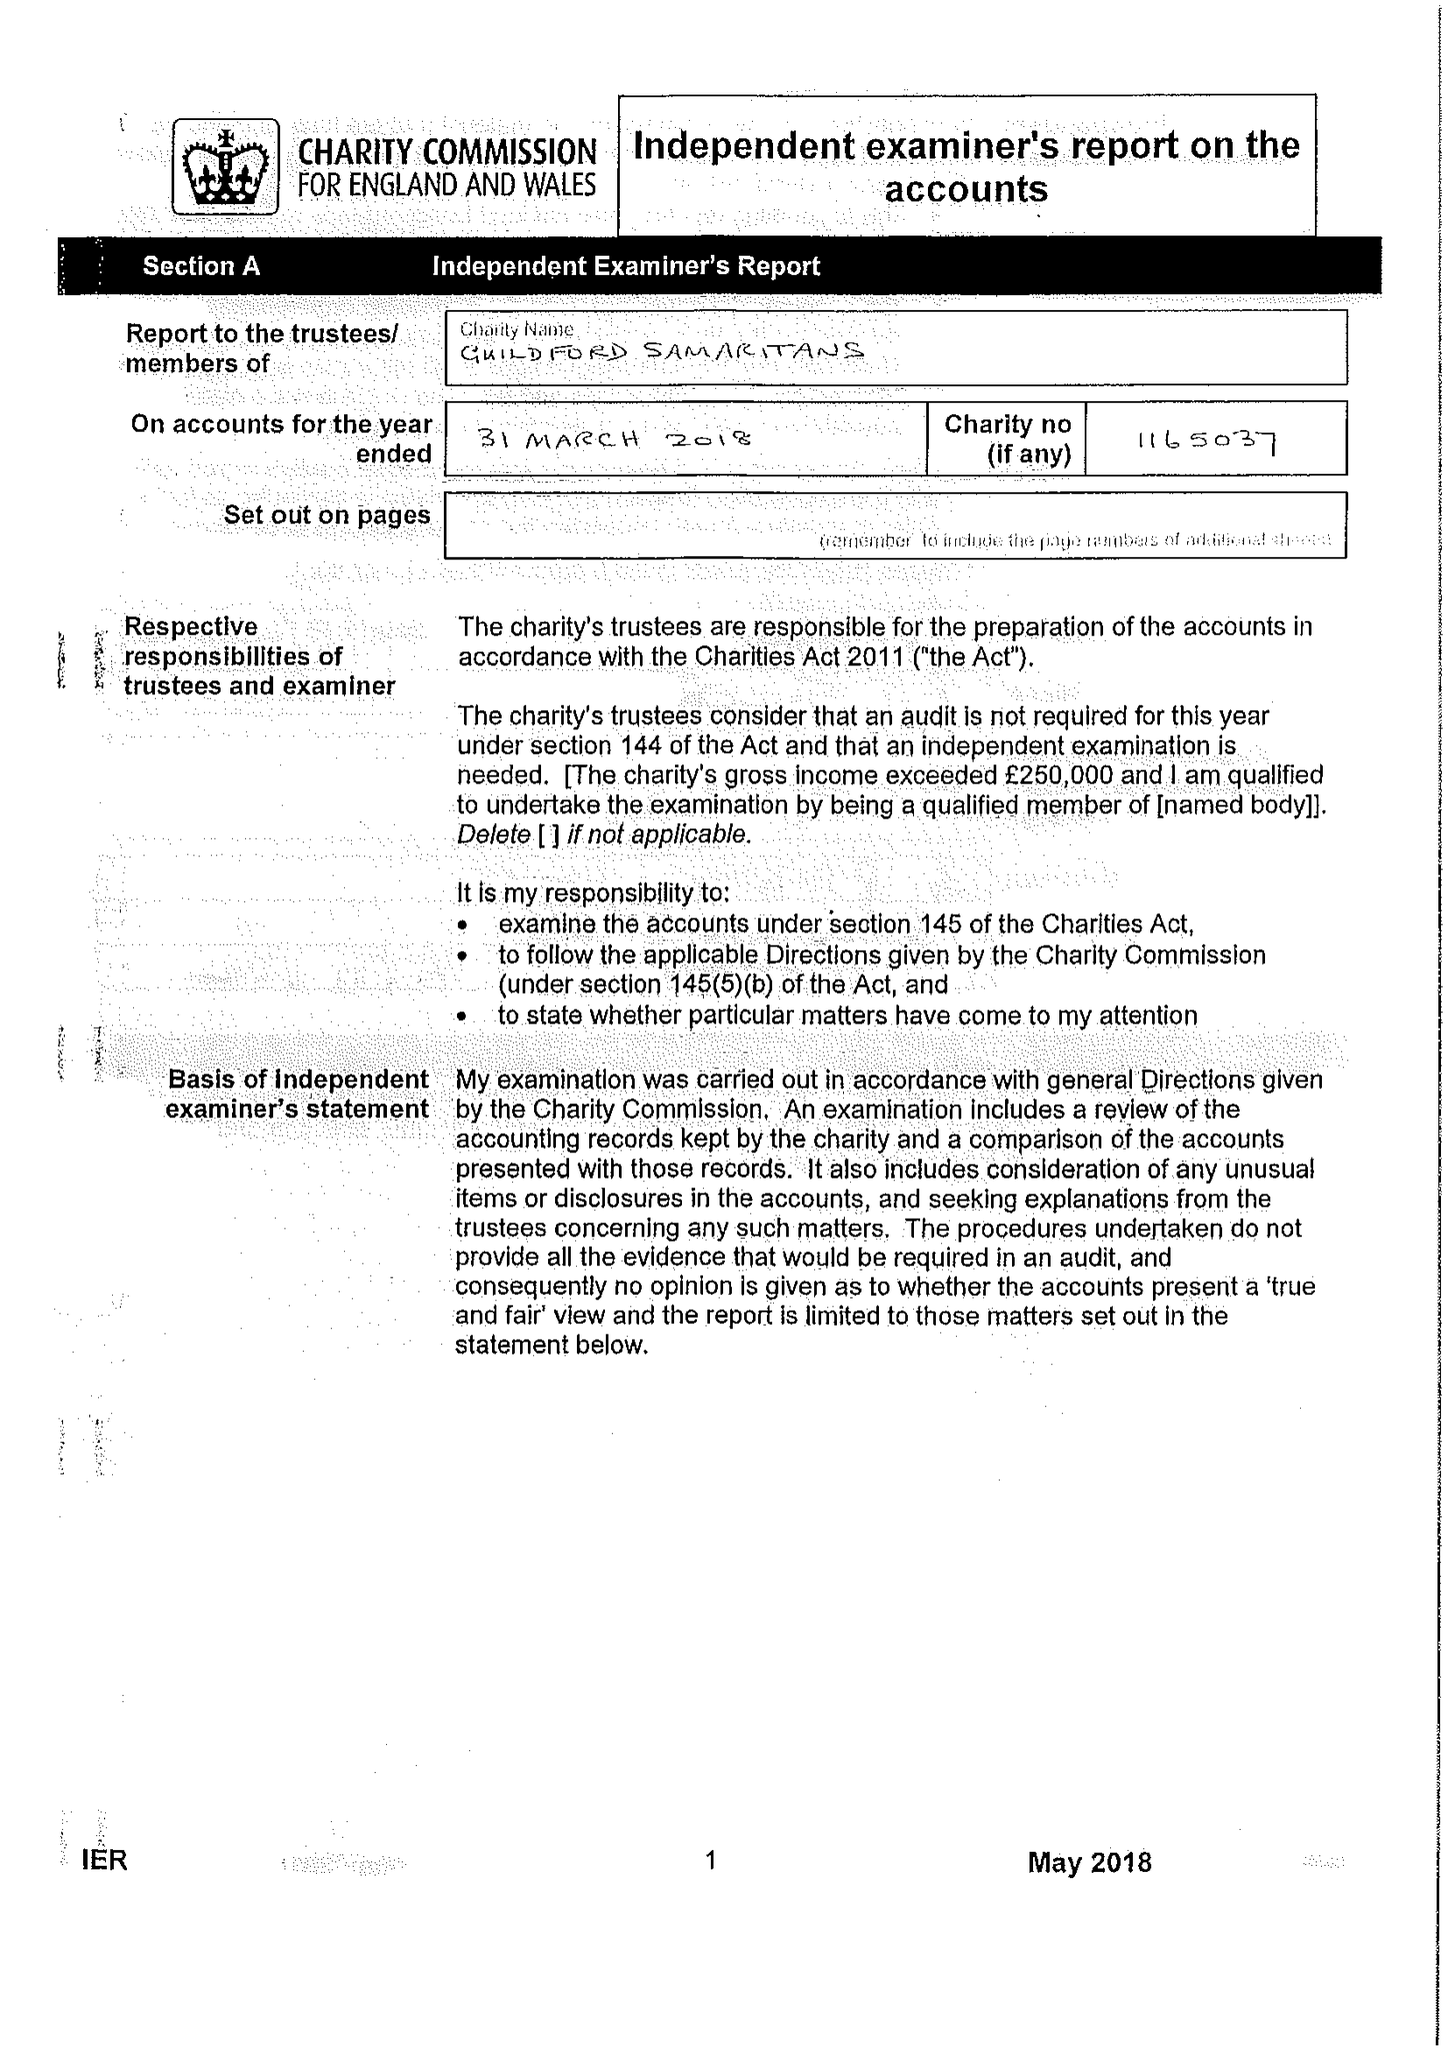What is the value for the charity_number?
Answer the question using a single word or phrase. 1165037 